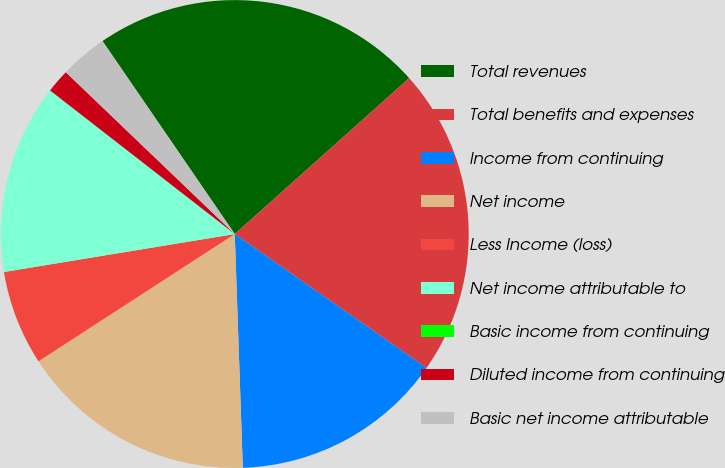Convert chart to OTSL. <chart><loc_0><loc_0><loc_500><loc_500><pie_chart><fcel>Total revenues<fcel>Total benefits and expenses<fcel>Income from continuing<fcel>Net income<fcel>Less Income (loss)<fcel>Net income attributable to<fcel>Basic income from continuing<fcel>Diluted income from continuing<fcel>Basic net income attributable<nl><fcel>22.95%<fcel>21.31%<fcel>14.75%<fcel>16.39%<fcel>6.56%<fcel>13.11%<fcel>0.0%<fcel>1.64%<fcel>3.28%<nl></chart> 